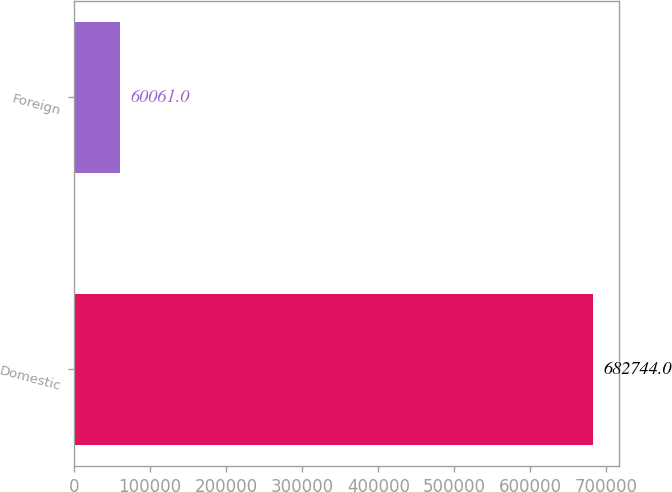Convert chart to OTSL. <chart><loc_0><loc_0><loc_500><loc_500><bar_chart><fcel>Domestic<fcel>Foreign<nl><fcel>682744<fcel>60061<nl></chart> 